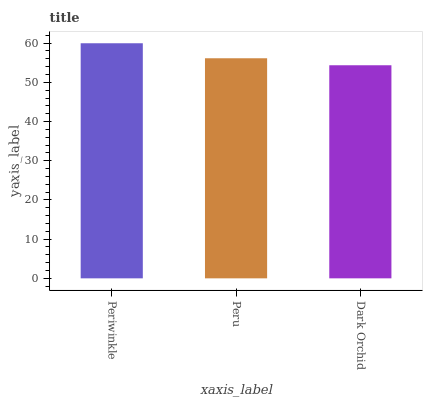Is Dark Orchid the minimum?
Answer yes or no. Yes. Is Periwinkle the maximum?
Answer yes or no. Yes. Is Peru the minimum?
Answer yes or no. No. Is Peru the maximum?
Answer yes or no. No. Is Periwinkle greater than Peru?
Answer yes or no. Yes. Is Peru less than Periwinkle?
Answer yes or no. Yes. Is Peru greater than Periwinkle?
Answer yes or no. No. Is Periwinkle less than Peru?
Answer yes or no. No. Is Peru the high median?
Answer yes or no. Yes. Is Peru the low median?
Answer yes or no. Yes. Is Periwinkle the high median?
Answer yes or no. No. Is Dark Orchid the low median?
Answer yes or no. No. 